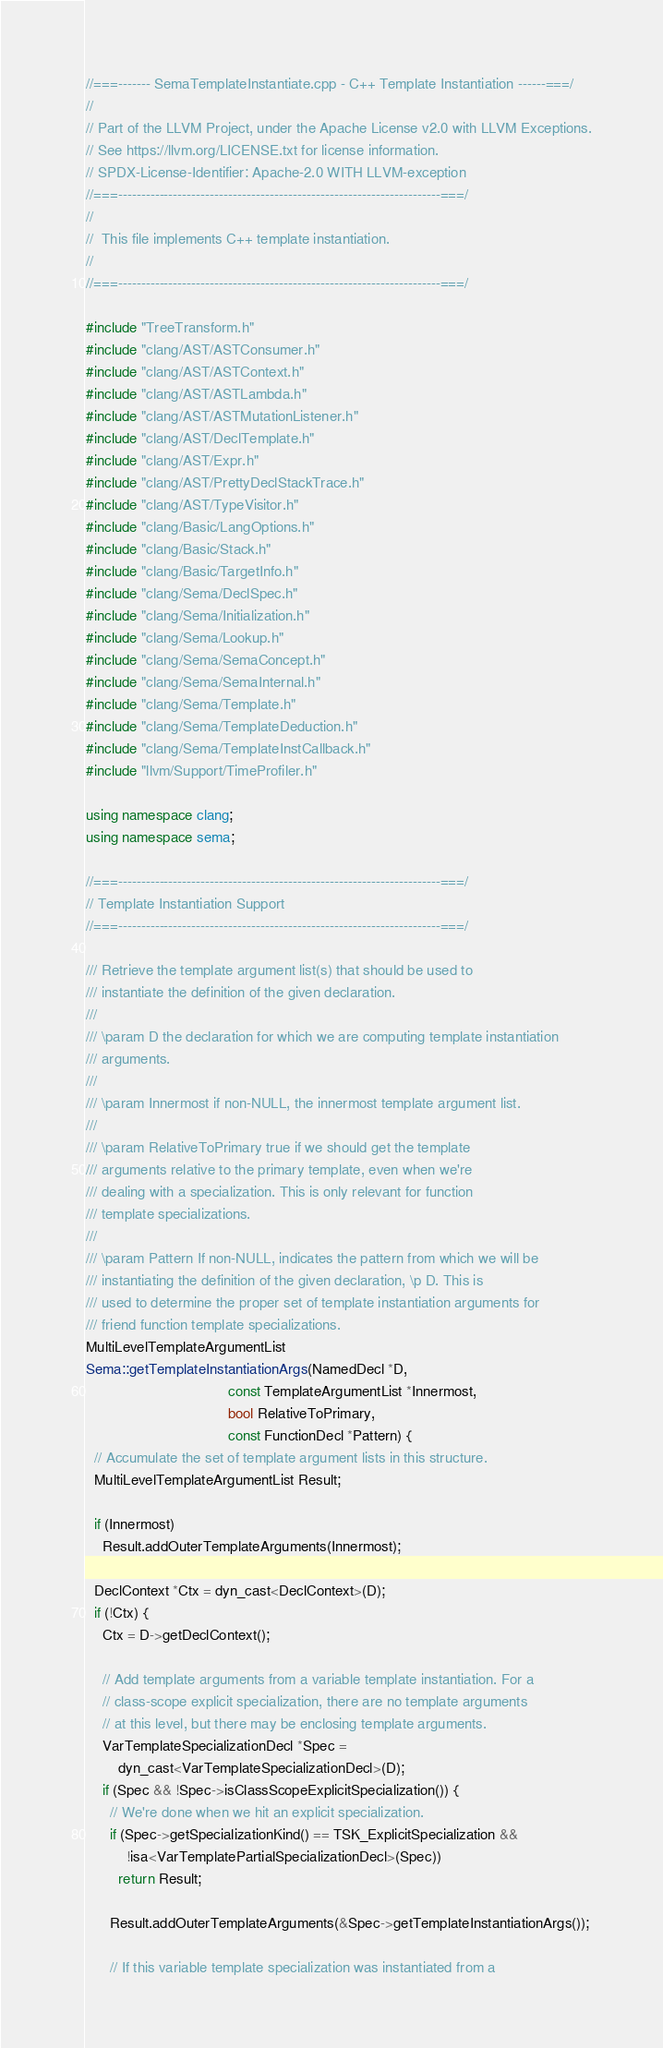<code> <loc_0><loc_0><loc_500><loc_500><_C++_>//===------- SemaTemplateInstantiate.cpp - C++ Template Instantiation ------===/
//
// Part of the LLVM Project, under the Apache License v2.0 with LLVM Exceptions.
// See https://llvm.org/LICENSE.txt for license information.
// SPDX-License-Identifier: Apache-2.0 WITH LLVM-exception
//===----------------------------------------------------------------------===/
//
//  This file implements C++ template instantiation.
//
//===----------------------------------------------------------------------===/

#include "TreeTransform.h"
#include "clang/AST/ASTConsumer.h"
#include "clang/AST/ASTContext.h"
#include "clang/AST/ASTLambda.h"
#include "clang/AST/ASTMutationListener.h"
#include "clang/AST/DeclTemplate.h"
#include "clang/AST/Expr.h"
#include "clang/AST/PrettyDeclStackTrace.h"
#include "clang/AST/TypeVisitor.h"
#include "clang/Basic/LangOptions.h"
#include "clang/Basic/Stack.h"
#include "clang/Basic/TargetInfo.h"
#include "clang/Sema/DeclSpec.h"
#include "clang/Sema/Initialization.h"
#include "clang/Sema/Lookup.h"
#include "clang/Sema/SemaConcept.h"
#include "clang/Sema/SemaInternal.h"
#include "clang/Sema/Template.h"
#include "clang/Sema/TemplateDeduction.h"
#include "clang/Sema/TemplateInstCallback.h"
#include "llvm/Support/TimeProfiler.h"

using namespace clang;
using namespace sema;

//===----------------------------------------------------------------------===/
// Template Instantiation Support
//===----------------------------------------------------------------------===/

/// Retrieve the template argument list(s) that should be used to
/// instantiate the definition of the given declaration.
///
/// \param D the declaration for which we are computing template instantiation
/// arguments.
///
/// \param Innermost if non-NULL, the innermost template argument list.
///
/// \param RelativeToPrimary true if we should get the template
/// arguments relative to the primary template, even when we're
/// dealing with a specialization. This is only relevant for function
/// template specializations.
///
/// \param Pattern If non-NULL, indicates the pattern from which we will be
/// instantiating the definition of the given declaration, \p D. This is
/// used to determine the proper set of template instantiation arguments for
/// friend function template specializations.
MultiLevelTemplateArgumentList
Sema::getTemplateInstantiationArgs(NamedDecl *D,
                                   const TemplateArgumentList *Innermost,
                                   bool RelativeToPrimary,
                                   const FunctionDecl *Pattern) {
  // Accumulate the set of template argument lists in this structure.
  MultiLevelTemplateArgumentList Result;

  if (Innermost)
    Result.addOuterTemplateArguments(Innermost);

  DeclContext *Ctx = dyn_cast<DeclContext>(D);
  if (!Ctx) {
    Ctx = D->getDeclContext();

    // Add template arguments from a variable template instantiation. For a
    // class-scope explicit specialization, there are no template arguments
    // at this level, but there may be enclosing template arguments.
    VarTemplateSpecializationDecl *Spec =
        dyn_cast<VarTemplateSpecializationDecl>(D);
    if (Spec && !Spec->isClassScopeExplicitSpecialization()) {
      // We're done when we hit an explicit specialization.
      if (Spec->getSpecializationKind() == TSK_ExplicitSpecialization &&
          !isa<VarTemplatePartialSpecializationDecl>(Spec))
        return Result;

      Result.addOuterTemplateArguments(&Spec->getTemplateInstantiationArgs());

      // If this variable template specialization was instantiated from a</code> 